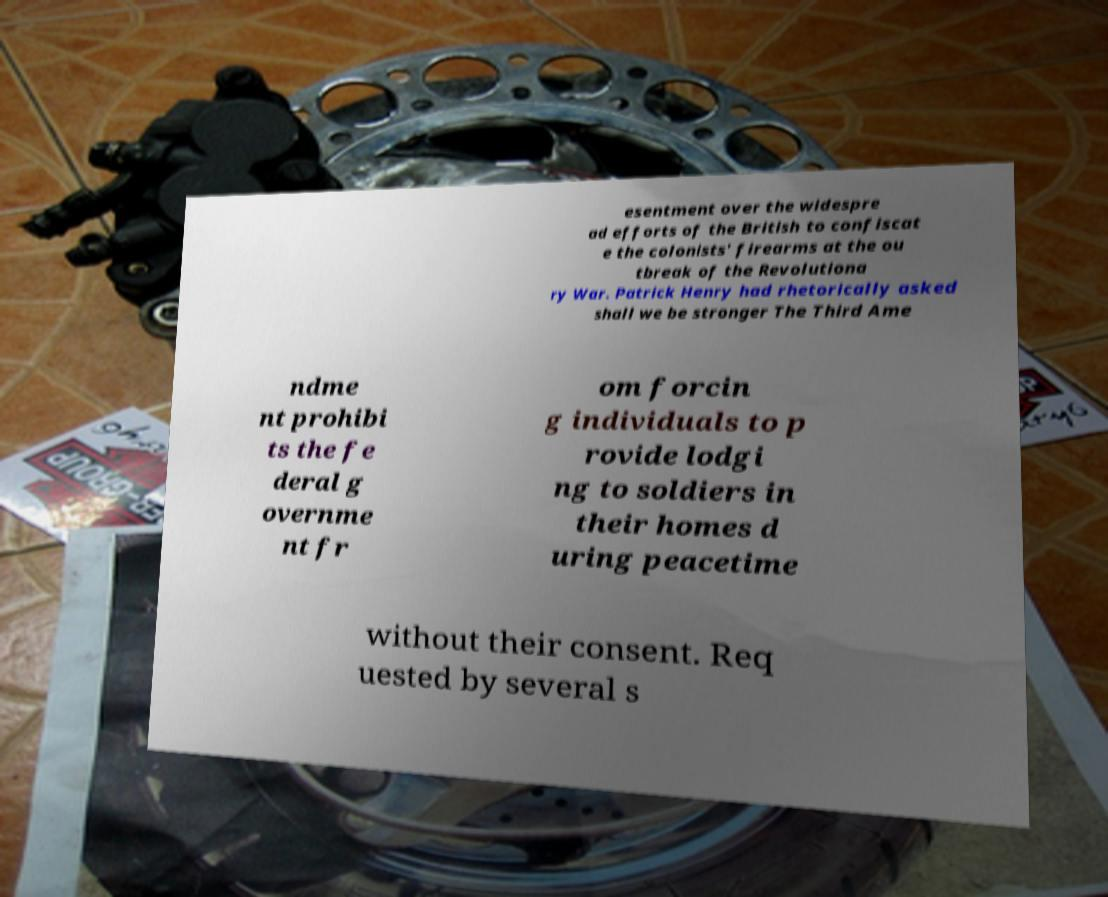Could you assist in decoding the text presented in this image and type it out clearly? esentment over the widespre ad efforts of the British to confiscat e the colonists' firearms at the ou tbreak of the Revolutiona ry War. Patrick Henry had rhetorically asked shall we be stronger The Third Ame ndme nt prohibi ts the fe deral g overnme nt fr om forcin g individuals to p rovide lodgi ng to soldiers in their homes d uring peacetime without their consent. Req uested by several s 